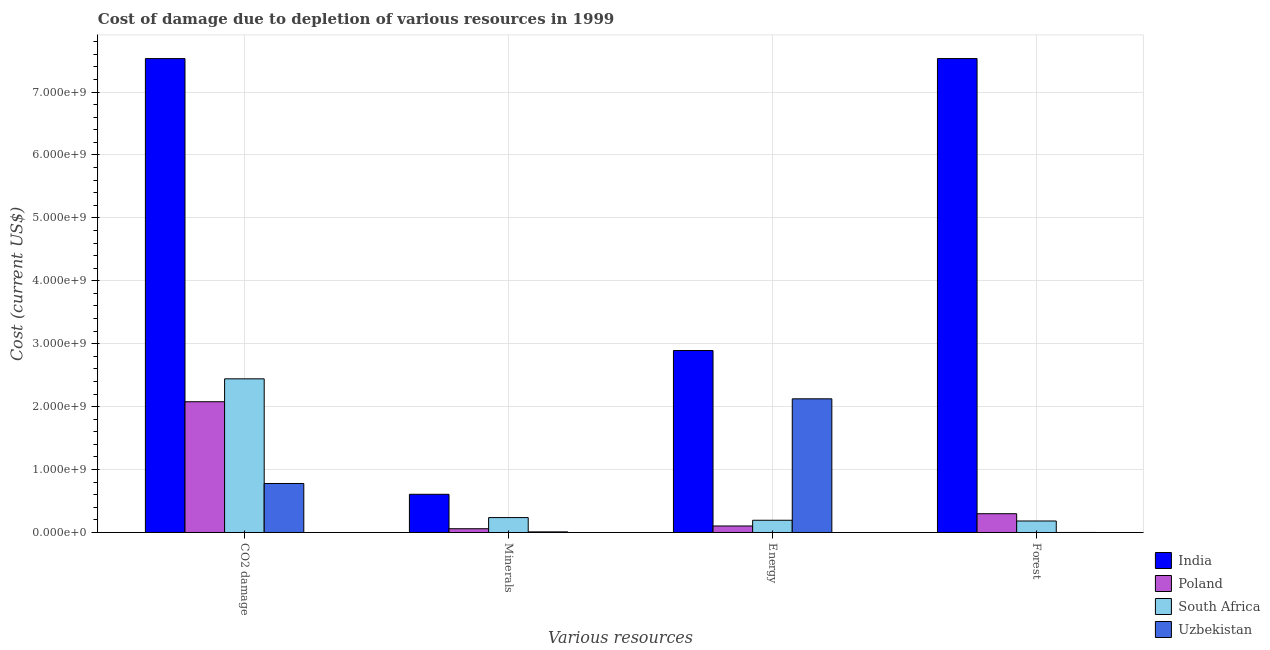How many different coloured bars are there?
Ensure brevity in your answer.  4. How many groups of bars are there?
Your response must be concise. 4. Are the number of bars per tick equal to the number of legend labels?
Ensure brevity in your answer.  Yes. What is the label of the 4th group of bars from the left?
Your answer should be compact. Forest. What is the cost of damage due to depletion of minerals in India?
Provide a succinct answer. 6.07e+08. Across all countries, what is the maximum cost of damage due to depletion of coal?
Offer a terse response. 7.53e+09. Across all countries, what is the minimum cost of damage due to depletion of energy?
Ensure brevity in your answer.  1.03e+08. In which country was the cost of damage due to depletion of forests maximum?
Provide a short and direct response. India. In which country was the cost of damage due to depletion of minerals minimum?
Your response must be concise. Uzbekistan. What is the total cost of damage due to depletion of forests in the graph?
Your answer should be very brief. 8.01e+09. What is the difference between the cost of damage due to depletion of forests in Uzbekistan and that in South Africa?
Give a very brief answer. -1.82e+08. What is the difference between the cost of damage due to depletion of minerals in South Africa and the cost of damage due to depletion of energy in Poland?
Make the answer very short. 1.33e+08. What is the average cost of damage due to depletion of energy per country?
Offer a terse response. 1.33e+09. What is the difference between the cost of damage due to depletion of minerals and cost of damage due to depletion of forests in Poland?
Offer a terse response. -2.39e+08. In how many countries, is the cost of damage due to depletion of energy greater than 6600000000 US$?
Provide a succinct answer. 0. What is the ratio of the cost of damage due to depletion of energy in Uzbekistan to that in South Africa?
Ensure brevity in your answer.  10.93. Is the cost of damage due to depletion of minerals in Uzbekistan less than that in South Africa?
Keep it short and to the point. Yes. What is the difference between the highest and the second highest cost of damage due to depletion of coal?
Offer a very short reply. 5.09e+09. What is the difference between the highest and the lowest cost of damage due to depletion of forests?
Make the answer very short. 7.53e+09. Is it the case that in every country, the sum of the cost of damage due to depletion of minerals and cost of damage due to depletion of coal is greater than the sum of cost of damage due to depletion of forests and cost of damage due to depletion of energy?
Provide a short and direct response. No. What does the 3rd bar from the right in Energy represents?
Give a very brief answer. Poland. Is it the case that in every country, the sum of the cost of damage due to depletion of coal and cost of damage due to depletion of minerals is greater than the cost of damage due to depletion of energy?
Offer a very short reply. No. Are all the bars in the graph horizontal?
Offer a very short reply. No. How many countries are there in the graph?
Make the answer very short. 4. Are the values on the major ticks of Y-axis written in scientific E-notation?
Ensure brevity in your answer.  Yes. How many legend labels are there?
Give a very brief answer. 4. What is the title of the graph?
Ensure brevity in your answer.  Cost of damage due to depletion of various resources in 1999 . What is the label or title of the X-axis?
Make the answer very short. Various resources. What is the label or title of the Y-axis?
Your response must be concise. Cost (current US$). What is the Cost (current US$) in India in CO2 damage?
Make the answer very short. 7.53e+09. What is the Cost (current US$) of Poland in CO2 damage?
Give a very brief answer. 2.08e+09. What is the Cost (current US$) of South Africa in CO2 damage?
Make the answer very short. 2.44e+09. What is the Cost (current US$) of Uzbekistan in CO2 damage?
Offer a terse response. 7.79e+08. What is the Cost (current US$) in India in Minerals?
Give a very brief answer. 6.07e+08. What is the Cost (current US$) in Poland in Minerals?
Provide a succinct answer. 5.97e+07. What is the Cost (current US$) of South Africa in Minerals?
Your answer should be very brief. 2.37e+08. What is the Cost (current US$) of Uzbekistan in Minerals?
Make the answer very short. 9.72e+06. What is the Cost (current US$) of India in Energy?
Give a very brief answer. 2.89e+09. What is the Cost (current US$) of Poland in Energy?
Offer a terse response. 1.03e+08. What is the Cost (current US$) in South Africa in Energy?
Ensure brevity in your answer.  1.94e+08. What is the Cost (current US$) in Uzbekistan in Energy?
Make the answer very short. 2.12e+09. What is the Cost (current US$) in India in Forest?
Keep it short and to the point. 7.53e+09. What is the Cost (current US$) of Poland in Forest?
Your answer should be compact. 2.98e+08. What is the Cost (current US$) in South Africa in Forest?
Your response must be concise. 1.83e+08. What is the Cost (current US$) in Uzbekistan in Forest?
Ensure brevity in your answer.  3.57e+05. Across all Various resources, what is the maximum Cost (current US$) in India?
Ensure brevity in your answer.  7.53e+09. Across all Various resources, what is the maximum Cost (current US$) of Poland?
Give a very brief answer. 2.08e+09. Across all Various resources, what is the maximum Cost (current US$) of South Africa?
Ensure brevity in your answer.  2.44e+09. Across all Various resources, what is the maximum Cost (current US$) of Uzbekistan?
Your answer should be very brief. 2.12e+09. Across all Various resources, what is the minimum Cost (current US$) in India?
Your answer should be very brief. 6.07e+08. Across all Various resources, what is the minimum Cost (current US$) of Poland?
Offer a terse response. 5.97e+07. Across all Various resources, what is the minimum Cost (current US$) in South Africa?
Give a very brief answer. 1.83e+08. Across all Various resources, what is the minimum Cost (current US$) in Uzbekistan?
Offer a terse response. 3.57e+05. What is the total Cost (current US$) in India in the graph?
Offer a very short reply. 1.86e+1. What is the total Cost (current US$) in Poland in the graph?
Your response must be concise. 2.54e+09. What is the total Cost (current US$) of South Africa in the graph?
Give a very brief answer. 3.06e+09. What is the total Cost (current US$) of Uzbekistan in the graph?
Your answer should be very brief. 2.91e+09. What is the difference between the Cost (current US$) of India in CO2 damage and that in Minerals?
Your response must be concise. 6.93e+09. What is the difference between the Cost (current US$) in Poland in CO2 damage and that in Minerals?
Give a very brief answer. 2.02e+09. What is the difference between the Cost (current US$) in South Africa in CO2 damage and that in Minerals?
Your answer should be very brief. 2.21e+09. What is the difference between the Cost (current US$) in Uzbekistan in CO2 damage and that in Minerals?
Offer a very short reply. 7.69e+08. What is the difference between the Cost (current US$) in India in CO2 damage and that in Energy?
Ensure brevity in your answer.  4.64e+09. What is the difference between the Cost (current US$) of Poland in CO2 damage and that in Energy?
Your answer should be compact. 1.97e+09. What is the difference between the Cost (current US$) in South Africa in CO2 damage and that in Energy?
Your answer should be very brief. 2.25e+09. What is the difference between the Cost (current US$) in Uzbekistan in CO2 damage and that in Energy?
Provide a succinct answer. -1.35e+09. What is the difference between the Cost (current US$) in India in CO2 damage and that in Forest?
Ensure brevity in your answer.  -3.76e+05. What is the difference between the Cost (current US$) of Poland in CO2 damage and that in Forest?
Provide a succinct answer. 1.78e+09. What is the difference between the Cost (current US$) of South Africa in CO2 damage and that in Forest?
Keep it short and to the point. 2.26e+09. What is the difference between the Cost (current US$) in Uzbekistan in CO2 damage and that in Forest?
Provide a short and direct response. 7.78e+08. What is the difference between the Cost (current US$) of India in Minerals and that in Energy?
Your answer should be compact. -2.29e+09. What is the difference between the Cost (current US$) of Poland in Minerals and that in Energy?
Ensure brevity in your answer.  -4.37e+07. What is the difference between the Cost (current US$) in South Africa in Minerals and that in Energy?
Ensure brevity in your answer.  4.25e+07. What is the difference between the Cost (current US$) of Uzbekistan in Minerals and that in Energy?
Ensure brevity in your answer.  -2.11e+09. What is the difference between the Cost (current US$) of India in Minerals and that in Forest?
Provide a short and direct response. -6.93e+09. What is the difference between the Cost (current US$) in Poland in Minerals and that in Forest?
Ensure brevity in your answer.  -2.39e+08. What is the difference between the Cost (current US$) of South Africa in Minerals and that in Forest?
Give a very brief answer. 5.40e+07. What is the difference between the Cost (current US$) in Uzbekistan in Minerals and that in Forest?
Offer a very short reply. 9.36e+06. What is the difference between the Cost (current US$) in India in Energy and that in Forest?
Make the answer very short. -4.64e+09. What is the difference between the Cost (current US$) in Poland in Energy and that in Forest?
Give a very brief answer. -1.95e+08. What is the difference between the Cost (current US$) in South Africa in Energy and that in Forest?
Provide a succinct answer. 1.16e+07. What is the difference between the Cost (current US$) of Uzbekistan in Energy and that in Forest?
Ensure brevity in your answer.  2.12e+09. What is the difference between the Cost (current US$) of India in CO2 damage and the Cost (current US$) of Poland in Minerals?
Provide a succinct answer. 7.47e+09. What is the difference between the Cost (current US$) in India in CO2 damage and the Cost (current US$) in South Africa in Minerals?
Provide a short and direct response. 7.30e+09. What is the difference between the Cost (current US$) of India in CO2 damage and the Cost (current US$) of Uzbekistan in Minerals?
Ensure brevity in your answer.  7.52e+09. What is the difference between the Cost (current US$) of Poland in CO2 damage and the Cost (current US$) of South Africa in Minerals?
Your response must be concise. 1.84e+09. What is the difference between the Cost (current US$) of Poland in CO2 damage and the Cost (current US$) of Uzbekistan in Minerals?
Provide a short and direct response. 2.07e+09. What is the difference between the Cost (current US$) of South Africa in CO2 damage and the Cost (current US$) of Uzbekistan in Minerals?
Your answer should be compact. 2.43e+09. What is the difference between the Cost (current US$) of India in CO2 damage and the Cost (current US$) of Poland in Energy?
Keep it short and to the point. 7.43e+09. What is the difference between the Cost (current US$) of India in CO2 damage and the Cost (current US$) of South Africa in Energy?
Ensure brevity in your answer.  7.34e+09. What is the difference between the Cost (current US$) of India in CO2 damage and the Cost (current US$) of Uzbekistan in Energy?
Offer a very short reply. 5.41e+09. What is the difference between the Cost (current US$) in Poland in CO2 damage and the Cost (current US$) in South Africa in Energy?
Your answer should be compact. 1.88e+09. What is the difference between the Cost (current US$) of Poland in CO2 damage and the Cost (current US$) of Uzbekistan in Energy?
Ensure brevity in your answer.  -4.65e+07. What is the difference between the Cost (current US$) in South Africa in CO2 damage and the Cost (current US$) in Uzbekistan in Energy?
Keep it short and to the point. 3.18e+08. What is the difference between the Cost (current US$) in India in CO2 damage and the Cost (current US$) in Poland in Forest?
Your response must be concise. 7.23e+09. What is the difference between the Cost (current US$) of India in CO2 damage and the Cost (current US$) of South Africa in Forest?
Provide a succinct answer. 7.35e+09. What is the difference between the Cost (current US$) in India in CO2 damage and the Cost (current US$) in Uzbekistan in Forest?
Offer a terse response. 7.53e+09. What is the difference between the Cost (current US$) of Poland in CO2 damage and the Cost (current US$) of South Africa in Forest?
Give a very brief answer. 1.90e+09. What is the difference between the Cost (current US$) of Poland in CO2 damage and the Cost (current US$) of Uzbekistan in Forest?
Your response must be concise. 2.08e+09. What is the difference between the Cost (current US$) in South Africa in CO2 damage and the Cost (current US$) in Uzbekistan in Forest?
Make the answer very short. 2.44e+09. What is the difference between the Cost (current US$) in India in Minerals and the Cost (current US$) in Poland in Energy?
Provide a succinct answer. 5.04e+08. What is the difference between the Cost (current US$) of India in Minerals and the Cost (current US$) of South Africa in Energy?
Your answer should be very brief. 4.13e+08. What is the difference between the Cost (current US$) in India in Minerals and the Cost (current US$) in Uzbekistan in Energy?
Make the answer very short. -1.52e+09. What is the difference between the Cost (current US$) in Poland in Minerals and the Cost (current US$) in South Africa in Energy?
Offer a very short reply. -1.35e+08. What is the difference between the Cost (current US$) of Poland in Minerals and the Cost (current US$) of Uzbekistan in Energy?
Ensure brevity in your answer.  -2.06e+09. What is the difference between the Cost (current US$) in South Africa in Minerals and the Cost (current US$) in Uzbekistan in Energy?
Your answer should be very brief. -1.89e+09. What is the difference between the Cost (current US$) of India in Minerals and the Cost (current US$) of Poland in Forest?
Ensure brevity in your answer.  3.09e+08. What is the difference between the Cost (current US$) in India in Minerals and the Cost (current US$) in South Africa in Forest?
Provide a succinct answer. 4.24e+08. What is the difference between the Cost (current US$) in India in Minerals and the Cost (current US$) in Uzbekistan in Forest?
Provide a short and direct response. 6.07e+08. What is the difference between the Cost (current US$) in Poland in Minerals and the Cost (current US$) in South Africa in Forest?
Your answer should be very brief. -1.23e+08. What is the difference between the Cost (current US$) in Poland in Minerals and the Cost (current US$) in Uzbekistan in Forest?
Your answer should be very brief. 5.94e+07. What is the difference between the Cost (current US$) in South Africa in Minerals and the Cost (current US$) in Uzbekistan in Forest?
Your answer should be very brief. 2.36e+08. What is the difference between the Cost (current US$) of India in Energy and the Cost (current US$) of Poland in Forest?
Keep it short and to the point. 2.59e+09. What is the difference between the Cost (current US$) of India in Energy and the Cost (current US$) of South Africa in Forest?
Provide a succinct answer. 2.71e+09. What is the difference between the Cost (current US$) in India in Energy and the Cost (current US$) in Uzbekistan in Forest?
Offer a very short reply. 2.89e+09. What is the difference between the Cost (current US$) of Poland in Energy and the Cost (current US$) of South Africa in Forest?
Your answer should be compact. -7.93e+07. What is the difference between the Cost (current US$) in Poland in Energy and the Cost (current US$) in Uzbekistan in Forest?
Offer a very short reply. 1.03e+08. What is the difference between the Cost (current US$) of South Africa in Energy and the Cost (current US$) of Uzbekistan in Forest?
Give a very brief answer. 1.94e+08. What is the average Cost (current US$) in India per Various resources?
Ensure brevity in your answer.  4.64e+09. What is the average Cost (current US$) of Poland per Various resources?
Your answer should be very brief. 6.35e+08. What is the average Cost (current US$) in South Africa per Various resources?
Ensure brevity in your answer.  7.64e+08. What is the average Cost (current US$) of Uzbekistan per Various resources?
Your answer should be compact. 7.28e+08. What is the difference between the Cost (current US$) in India and Cost (current US$) in Poland in CO2 damage?
Offer a terse response. 5.45e+09. What is the difference between the Cost (current US$) in India and Cost (current US$) in South Africa in CO2 damage?
Your answer should be very brief. 5.09e+09. What is the difference between the Cost (current US$) in India and Cost (current US$) in Uzbekistan in CO2 damage?
Keep it short and to the point. 6.75e+09. What is the difference between the Cost (current US$) in Poland and Cost (current US$) in South Africa in CO2 damage?
Your answer should be compact. -3.64e+08. What is the difference between the Cost (current US$) of Poland and Cost (current US$) of Uzbekistan in CO2 damage?
Provide a short and direct response. 1.30e+09. What is the difference between the Cost (current US$) of South Africa and Cost (current US$) of Uzbekistan in CO2 damage?
Your answer should be very brief. 1.66e+09. What is the difference between the Cost (current US$) of India and Cost (current US$) of Poland in Minerals?
Ensure brevity in your answer.  5.47e+08. What is the difference between the Cost (current US$) in India and Cost (current US$) in South Africa in Minerals?
Your answer should be very brief. 3.70e+08. What is the difference between the Cost (current US$) of India and Cost (current US$) of Uzbekistan in Minerals?
Provide a short and direct response. 5.97e+08. What is the difference between the Cost (current US$) of Poland and Cost (current US$) of South Africa in Minerals?
Your response must be concise. -1.77e+08. What is the difference between the Cost (current US$) of Poland and Cost (current US$) of Uzbekistan in Minerals?
Provide a short and direct response. 5.00e+07. What is the difference between the Cost (current US$) in South Africa and Cost (current US$) in Uzbekistan in Minerals?
Ensure brevity in your answer.  2.27e+08. What is the difference between the Cost (current US$) in India and Cost (current US$) in Poland in Energy?
Keep it short and to the point. 2.79e+09. What is the difference between the Cost (current US$) in India and Cost (current US$) in South Africa in Energy?
Offer a terse response. 2.70e+09. What is the difference between the Cost (current US$) of India and Cost (current US$) of Uzbekistan in Energy?
Your answer should be compact. 7.68e+08. What is the difference between the Cost (current US$) in Poland and Cost (current US$) in South Africa in Energy?
Ensure brevity in your answer.  -9.09e+07. What is the difference between the Cost (current US$) of Poland and Cost (current US$) of Uzbekistan in Energy?
Ensure brevity in your answer.  -2.02e+09. What is the difference between the Cost (current US$) in South Africa and Cost (current US$) in Uzbekistan in Energy?
Your answer should be compact. -1.93e+09. What is the difference between the Cost (current US$) of India and Cost (current US$) of Poland in Forest?
Provide a short and direct response. 7.23e+09. What is the difference between the Cost (current US$) of India and Cost (current US$) of South Africa in Forest?
Offer a very short reply. 7.35e+09. What is the difference between the Cost (current US$) of India and Cost (current US$) of Uzbekistan in Forest?
Make the answer very short. 7.53e+09. What is the difference between the Cost (current US$) of Poland and Cost (current US$) of South Africa in Forest?
Give a very brief answer. 1.16e+08. What is the difference between the Cost (current US$) in Poland and Cost (current US$) in Uzbekistan in Forest?
Your response must be concise. 2.98e+08. What is the difference between the Cost (current US$) in South Africa and Cost (current US$) in Uzbekistan in Forest?
Keep it short and to the point. 1.82e+08. What is the ratio of the Cost (current US$) of India in CO2 damage to that in Minerals?
Keep it short and to the point. 12.41. What is the ratio of the Cost (current US$) in Poland in CO2 damage to that in Minerals?
Provide a succinct answer. 34.78. What is the ratio of the Cost (current US$) in South Africa in CO2 damage to that in Minerals?
Ensure brevity in your answer.  10.31. What is the ratio of the Cost (current US$) in Uzbekistan in CO2 damage to that in Minerals?
Give a very brief answer. 80.12. What is the ratio of the Cost (current US$) in India in CO2 damage to that in Energy?
Keep it short and to the point. 2.6. What is the ratio of the Cost (current US$) in Poland in CO2 damage to that in Energy?
Offer a very short reply. 20.08. What is the ratio of the Cost (current US$) in South Africa in CO2 damage to that in Energy?
Provide a succinct answer. 12.57. What is the ratio of the Cost (current US$) of Uzbekistan in CO2 damage to that in Energy?
Offer a terse response. 0.37. What is the ratio of the Cost (current US$) in India in CO2 damage to that in Forest?
Keep it short and to the point. 1. What is the ratio of the Cost (current US$) in Poland in CO2 damage to that in Forest?
Offer a terse response. 6.96. What is the ratio of the Cost (current US$) in South Africa in CO2 damage to that in Forest?
Your answer should be very brief. 13.36. What is the ratio of the Cost (current US$) of Uzbekistan in CO2 damage to that in Forest?
Give a very brief answer. 2178.7. What is the ratio of the Cost (current US$) of India in Minerals to that in Energy?
Your response must be concise. 0.21. What is the ratio of the Cost (current US$) of Poland in Minerals to that in Energy?
Provide a succinct answer. 0.58. What is the ratio of the Cost (current US$) of South Africa in Minerals to that in Energy?
Your answer should be compact. 1.22. What is the ratio of the Cost (current US$) of Uzbekistan in Minerals to that in Energy?
Provide a succinct answer. 0. What is the ratio of the Cost (current US$) in India in Minerals to that in Forest?
Your answer should be compact. 0.08. What is the ratio of the Cost (current US$) of Poland in Minerals to that in Forest?
Provide a short and direct response. 0.2. What is the ratio of the Cost (current US$) of South Africa in Minerals to that in Forest?
Your response must be concise. 1.3. What is the ratio of the Cost (current US$) of Uzbekistan in Minerals to that in Forest?
Your answer should be very brief. 27.19. What is the ratio of the Cost (current US$) in India in Energy to that in Forest?
Offer a very short reply. 0.38. What is the ratio of the Cost (current US$) in Poland in Energy to that in Forest?
Ensure brevity in your answer.  0.35. What is the ratio of the Cost (current US$) of South Africa in Energy to that in Forest?
Ensure brevity in your answer.  1.06. What is the ratio of the Cost (current US$) of Uzbekistan in Energy to that in Forest?
Your response must be concise. 5943.67. What is the difference between the highest and the second highest Cost (current US$) in India?
Provide a short and direct response. 3.76e+05. What is the difference between the highest and the second highest Cost (current US$) of Poland?
Your response must be concise. 1.78e+09. What is the difference between the highest and the second highest Cost (current US$) of South Africa?
Keep it short and to the point. 2.21e+09. What is the difference between the highest and the second highest Cost (current US$) of Uzbekistan?
Offer a terse response. 1.35e+09. What is the difference between the highest and the lowest Cost (current US$) in India?
Give a very brief answer. 6.93e+09. What is the difference between the highest and the lowest Cost (current US$) of Poland?
Provide a short and direct response. 2.02e+09. What is the difference between the highest and the lowest Cost (current US$) of South Africa?
Provide a succinct answer. 2.26e+09. What is the difference between the highest and the lowest Cost (current US$) of Uzbekistan?
Offer a very short reply. 2.12e+09. 